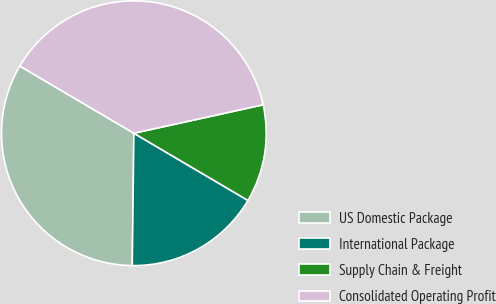Convert chart to OTSL. <chart><loc_0><loc_0><loc_500><loc_500><pie_chart><fcel>US Domestic Package<fcel>International Package<fcel>Supply Chain & Freight<fcel>Consolidated Operating Profit<nl><fcel>33.28%<fcel>16.72%<fcel>11.92%<fcel>38.08%<nl></chart> 